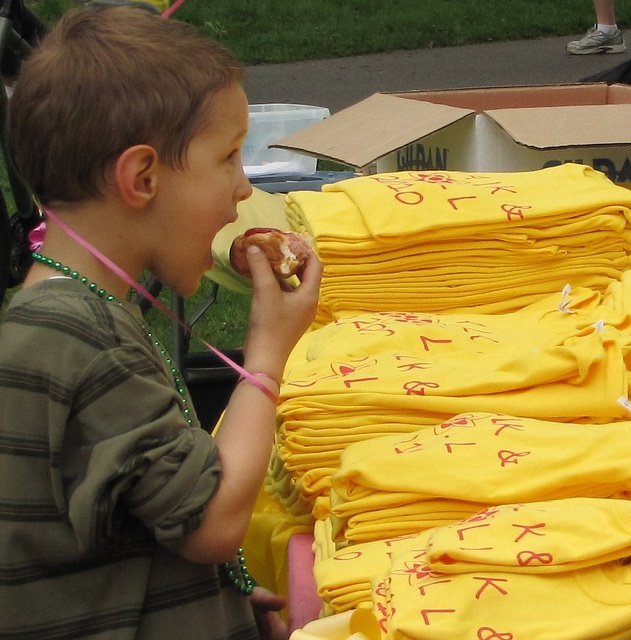Describe the objects in this image and their specific colors. I can see people in black, gray, maroon, and brown tones, hot dog in black, brown, maroon, salmon, and tan tones, and people in black, gray, and maroon tones in this image. 